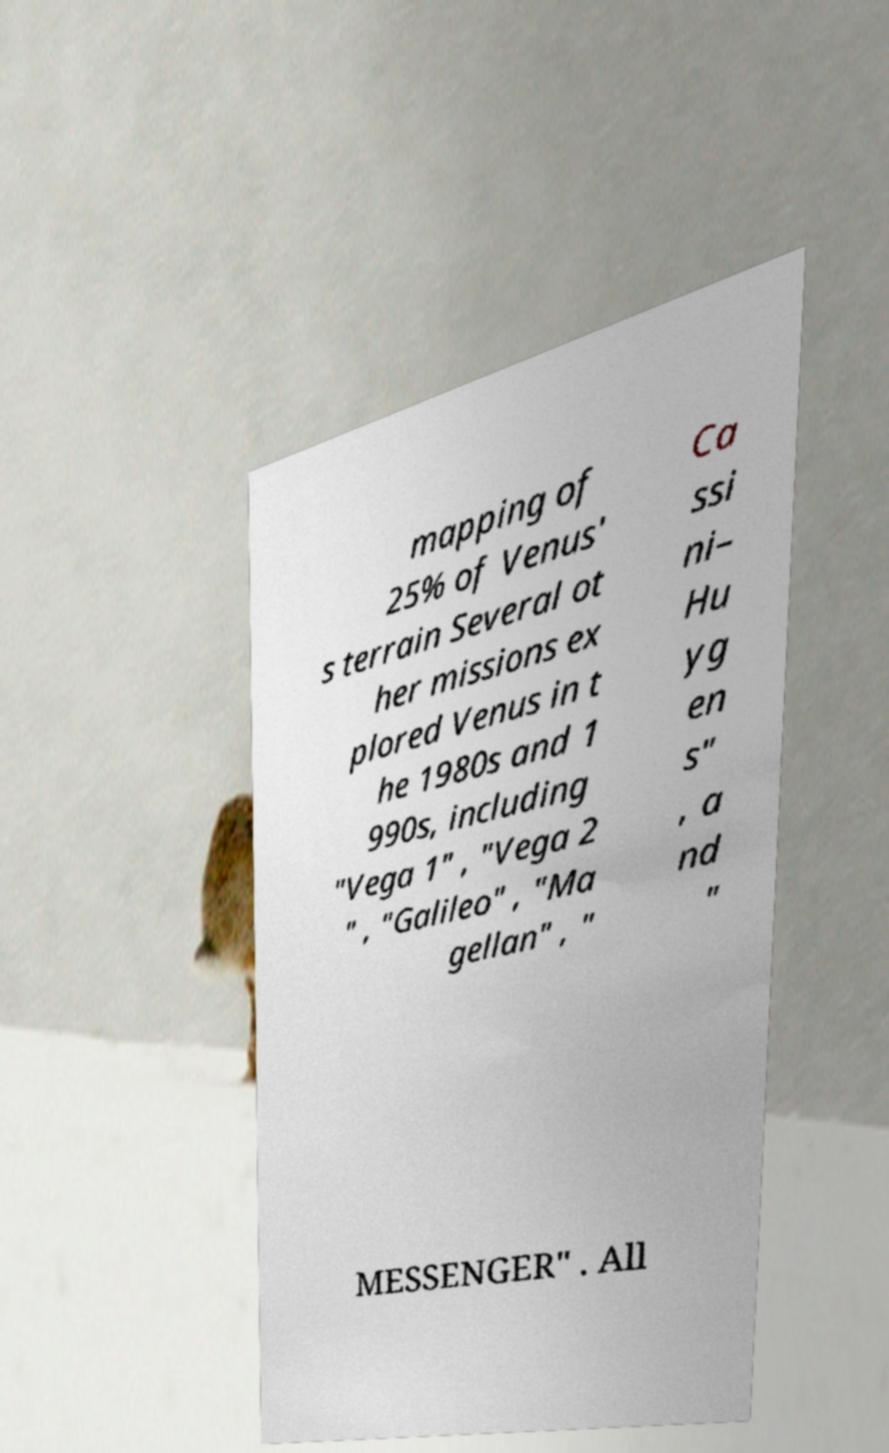What messages or text are displayed in this image? I need them in a readable, typed format. mapping of 25% of Venus' s terrain Several ot her missions ex plored Venus in t he 1980s and 1 990s, including "Vega 1" , "Vega 2 " , "Galileo" , "Ma gellan" , " Ca ssi ni– Hu yg en s" , a nd " MESSENGER" . All 